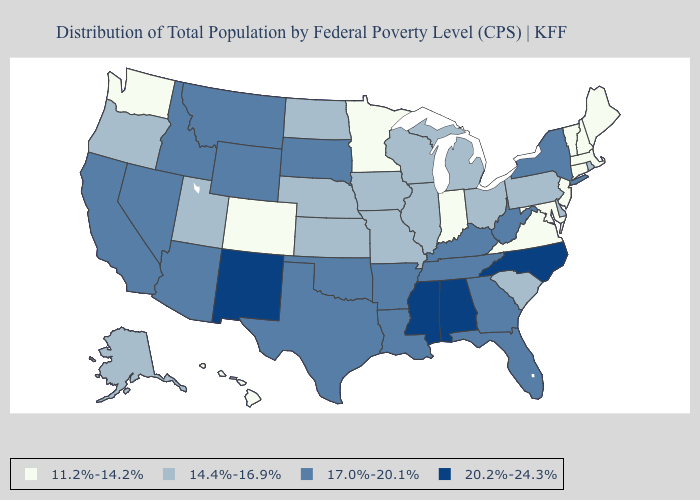What is the lowest value in states that border Missouri?
Write a very short answer. 14.4%-16.9%. What is the lowest value in states that border Rhode Island?
Short answer required. 11.2%-14.2%. Does New Mexico have the highest value in the West?
Keep it brief. Yes. What is the value of Idaho?
Be succinct. 17.0%-20.1%. What is the value of Arkansas?
Write a very short answer. 17.0%-20.1%. Does the first symbol in the legend represent the smallest category?
Give a very brief answer. Yes. Name the states that have a value in the range 17.0%-20.1%?
Short answer required. Arizona, Arkansas, California, Florida, Georgia, Idaho, Kentucky, Louisiana, Montana, Nevada, New York, Oklahoma, South Dakota, Tennessee, Texas, West Virginia, Wyoming. Does Arizona have the highest value in the USA?
Be succinct. No. Name the states that have a value in the range 20.2%-24.3%?
Short answer required. Alabama, Mississippi, New Mexico, North Carolina. Does New Hampshire have the same value as Virginia?
Keep it brief. Yes. How many symbols are there in the legend?
Give a very brief answer. 4. Name the states that have a value in the range 14.4%-16.9%?
Give a very brief answer. Alaska, Delaware, Illinois, Iowa, Kansas, Michigan, Missouri, Nebraska, North Dakota, Ohio, Oregon, Pennsylvania, Rhode Island, South Carolina, Utah, Wisconsin. Name the states that have a value in the range 17.0%-20.1%?
Concise answer only. Arizona, Arkansas, California, Florida, Georgia, Idaho, Kentucky, Louisiana, Montana, Nevada, New York, Oklahoma, South Dakota, Tennessee, Texas, West Virginia, Wyoming. Which states have the lowest value in the MidWest?
Short answer required. Indiana, Minnesota. Among the states that border Maine , which have the lowest value?
Answer briefly. New Hampshire. 